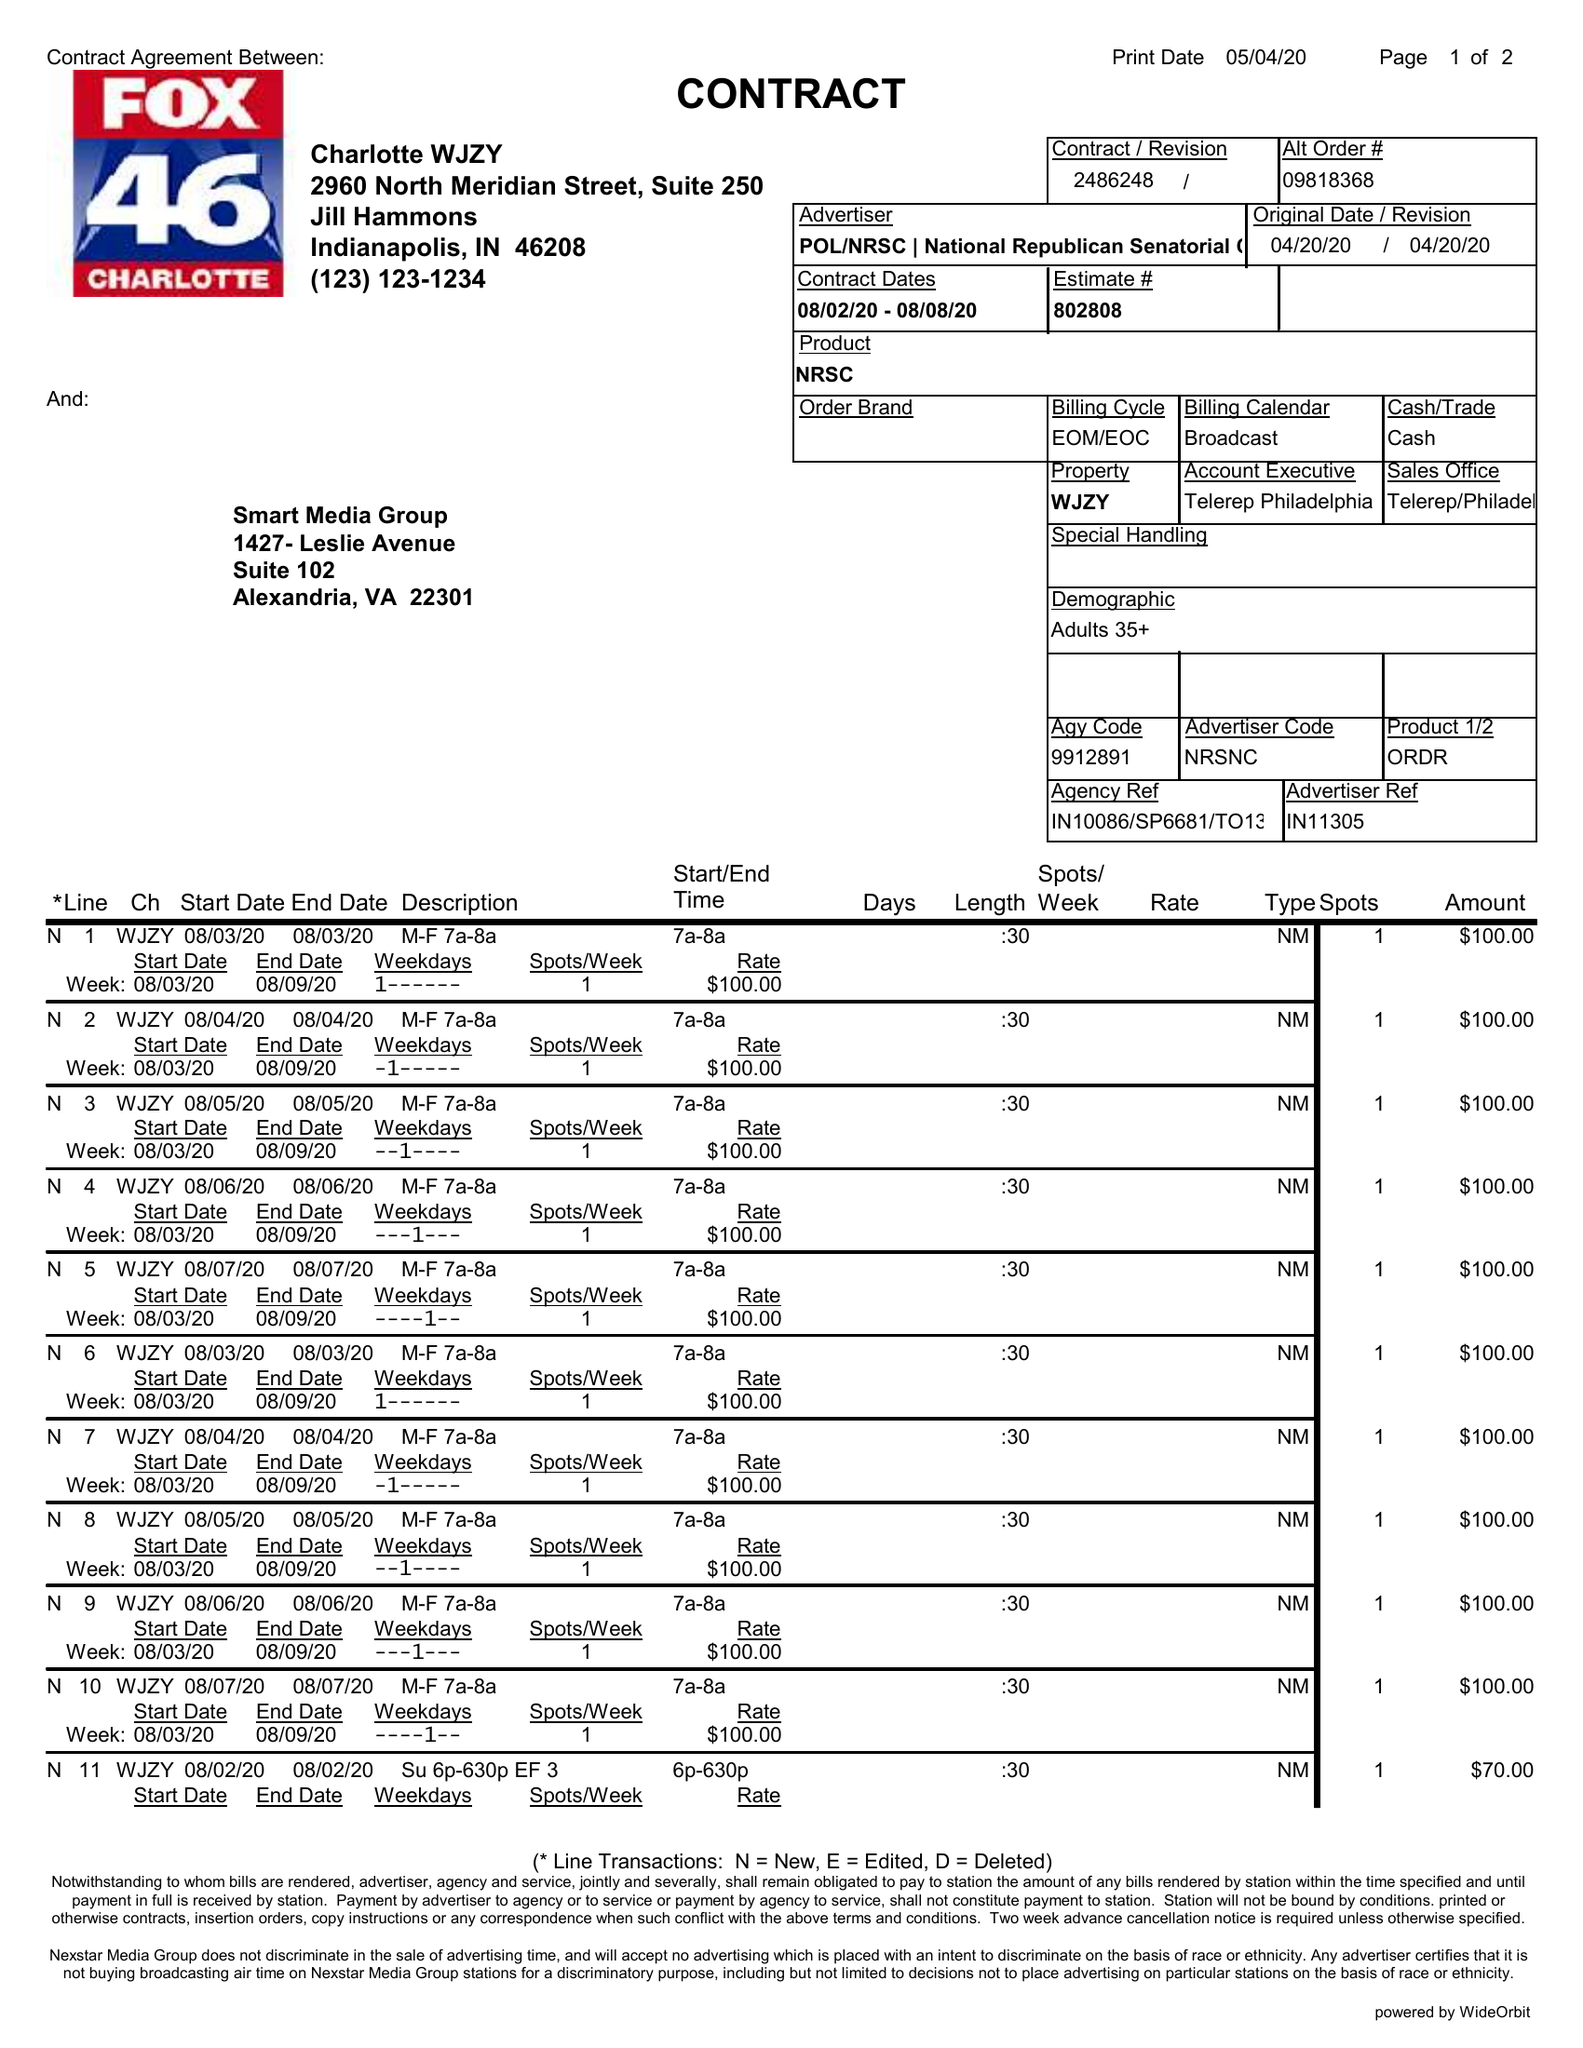What is the value for the contract_num?
Answer the question using a single word or phrase. 2486248 